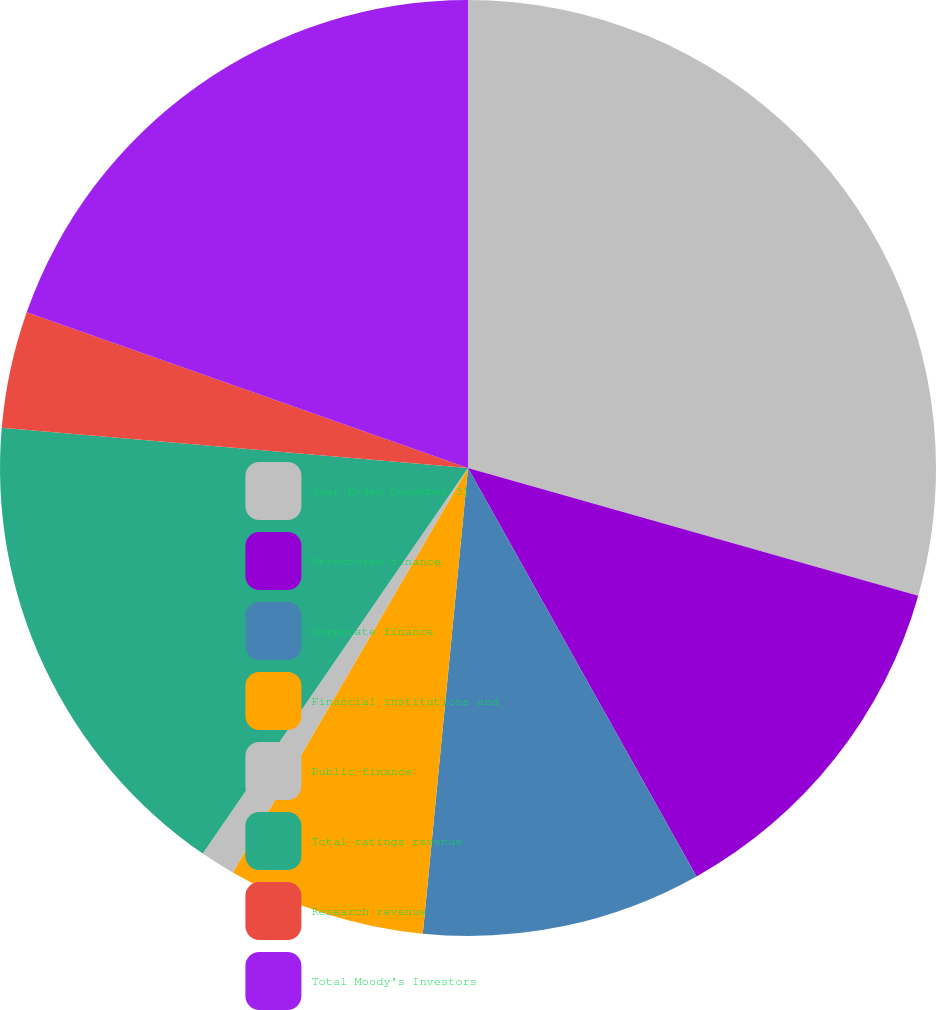<chart> <loc_0><loc_0><loc_500><loc_500><pie_chart><fcel>Year Ended December 31<fcel>Structured finance<fcel>Corporate finance<fcel>Financial institutions and<fcel>Public finance<fcel>Total ratings revenue<fcel>Research revenue<fcel>Total Moody's Investors<nl><fcel>29.4%<fcel>12.48%<fcel>9.66%<fcel>6.84%<fcel>1.21%<fcel>16.78%<fcel>4.03%<fcel>19.6%<nl></chart> 